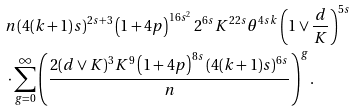<formula> <loc_0><loc_0><loc_500><loc_500>& n ( 4 ( k + 1 ) s ) ^ { 2 s + 3 } \left ( 1 + 4 p \right ) ^ { 1 6 s ^ { 2 } } 2 ^ { 6 s } K ^ { 2 2 s } \theta ^ { 4 s k } \left ( 1 \vee \frac { d } { K } \right ) ^ { 5 s } \\ & \cdot \sum _ { g = 0 } ^ { \infty } \left ( \frac { 2 ( d \vee K ) ^ { 3 } K ^ { 9 } \left ( 1 + 4 p \right ) ^ { 8 s } ( 4 ( k + 1 ) s ) ^ { 6 s } } { n } \right ) ^ { g } .</formula> 